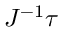<formula> <loc_0><loc_0><loc_500><loc_500>J ^ { - 1 } { \tau }</formula> 